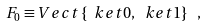<formula> <loc_0><loc_0><loc_500><loc_500>F _ { 0 } \equiv V e c t \left \{ \ k e t { 0 } , \ k e t { 1 } \right \} \ ,</formula> 